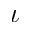<formula> <loc_0><loc_0><loc_500><loc_500>\iota</formula> 